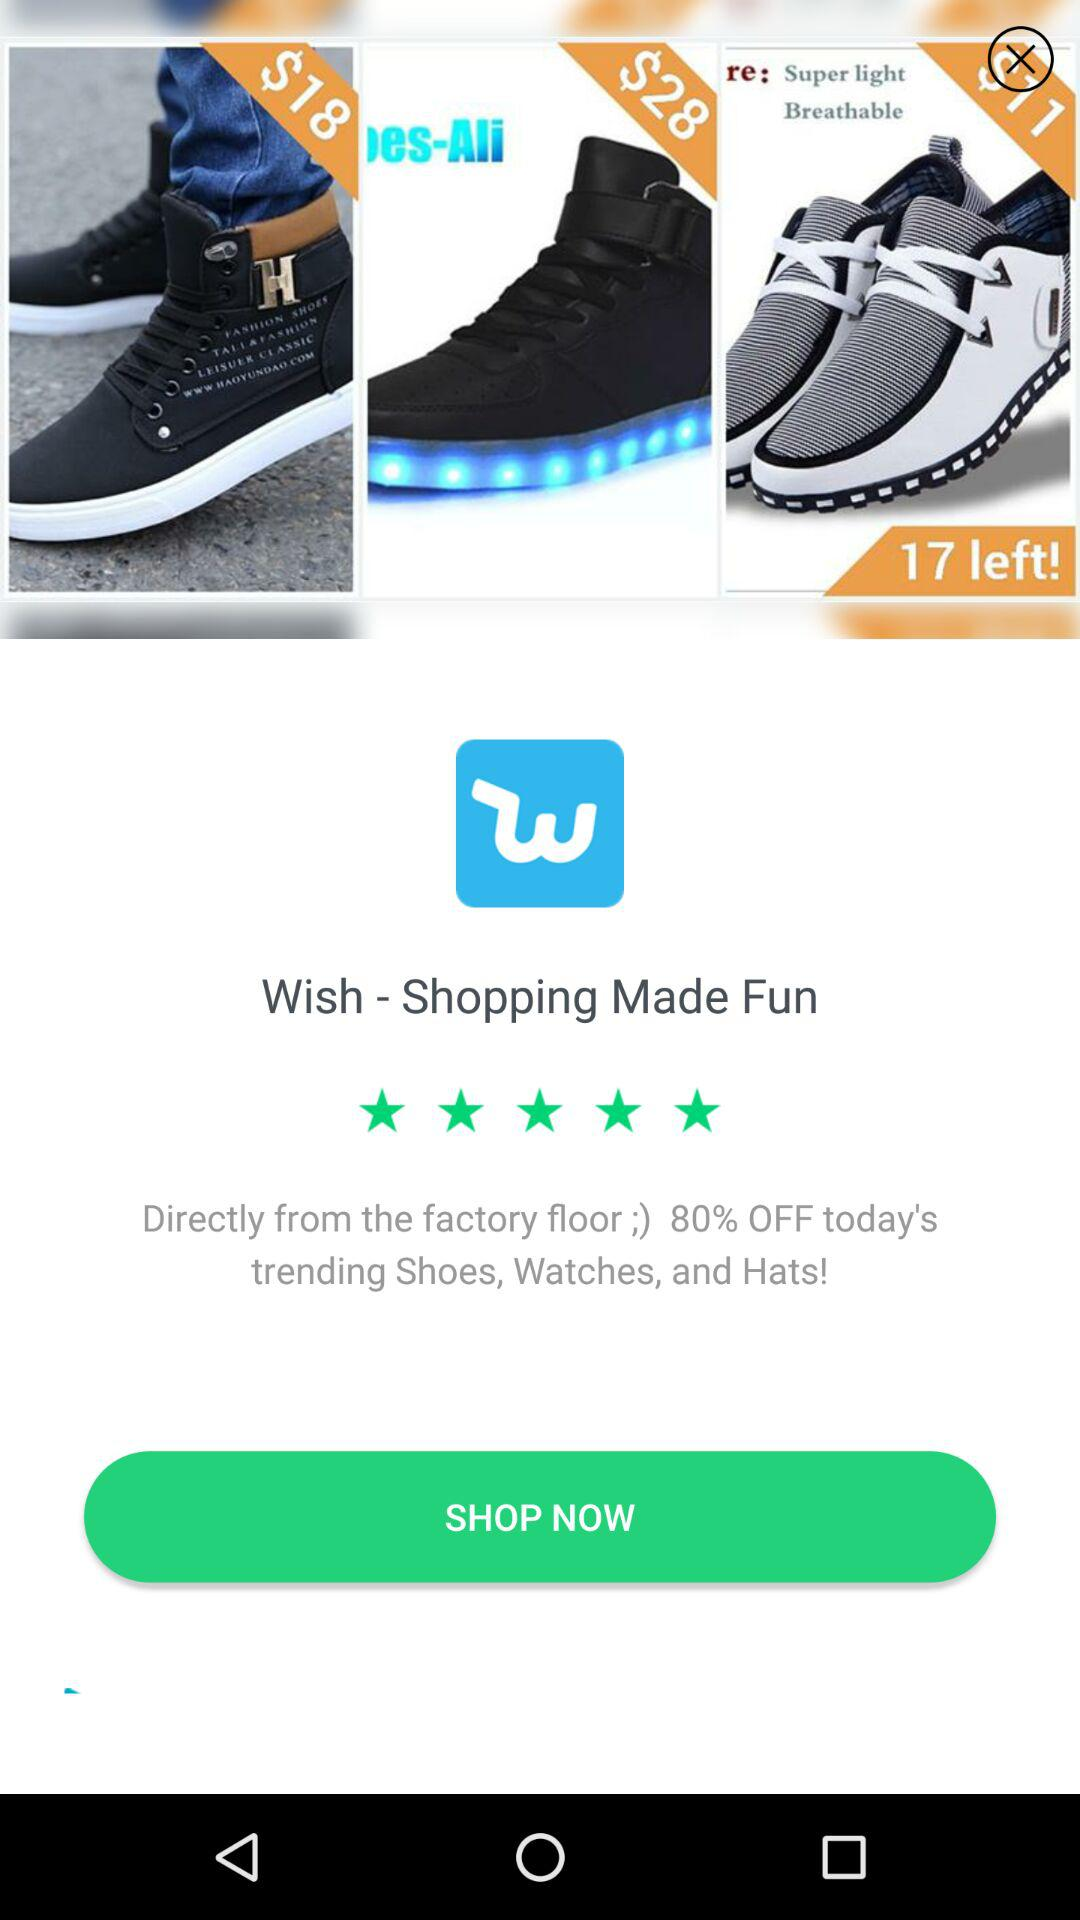How much of the discount will we get? You will get the 80% discount. 